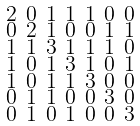<formula> <loc_0><loc_0><loc_500><loc_500>\begin{smallmatrix} 2 & 0 & 1 & 1 & 1 & 0 & 0 \\ 0 & 2 & 1 & 0 & 0 & 1 & 1 \\ 1 & 1 & 3 & 1 & 1 & 1 & 0 \\ 1 & 0 & 1 & 3 & 1 & 0 & 1 \\ 1 & 0 & 1 & 1 & 3 & 0 & 0 \\ 0 & 1 & 1 & 0 & 0 & 3 & 0 \\ 0 & 1 & 0 & 1 & 0 & 0 & 3 \end{smallmatrix}</formula> 